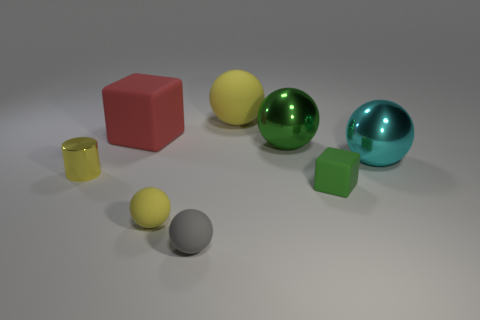What number of rubber objects are yellow things or tiny spheres?
Ensure brevity in your answer.  3. There is a yellow ball in front of the big red rubber object; how many yellow metal cylinders are on the left side of it?
Offer a very short reply. 1. How many large red blocks have the same material as the small gray sphere?
Make the answer very short. 1. What number of small things are blue objects or balls?
Give a very brief answer. 2. There is a yellow thing that is to the left of the tiny gray object and behind the tiny cube; what shape is it?
Give a very brief answer. Cylinder. Is the green block made of the same material as the small yellow cylinder?
Provide a short and direct response. No. What is the color of the rubber sphere that is the same size as the red block?
Make the answer very short. Yellow. What color is the thing that is both behind the green shiny object and left of the large yellow rubber object?
Provide a short and direct response. Red. There is a shiny object that is the same color as the small matte block; what is its size?
Your answer should be compact. Large. What is the shape of the tiny object that is the same color as the cylinder?
Ensure brevity in your answer.  Sphere. 